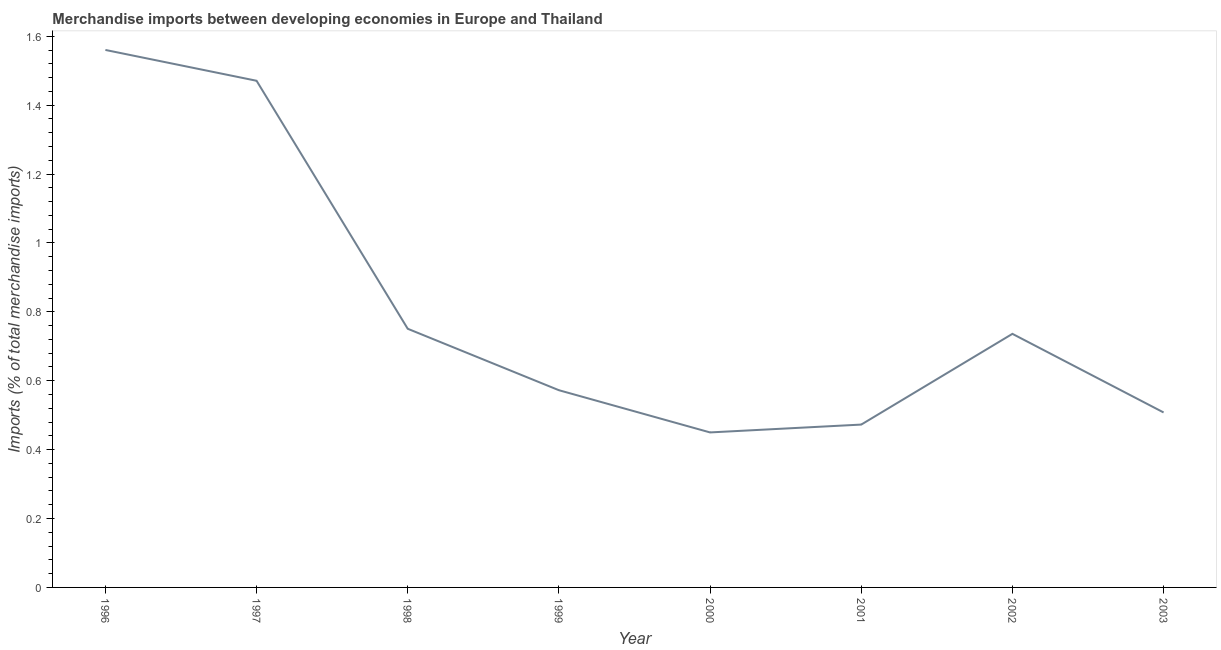What is the merchandise imports in 2002?
Your answer should be compact. 0.74. Across all years, what is the maximum merchandise imports?
Offer a very short reply. 1.56. Across all years, what is the minimum merchandise imports?
Provide a short and direct response. 0.45. What is the sum of the merchandise imports?
Make the answer very short. 6.52. What is the difference between the merchandise imports in 1996 and 1999?
Provide a succinct answer. 0.99. What is the average merchandise imports per year?
Your response must be concise. 0.82. What is the median merchandise imports?
Offer a very short reply. 0.65. In how many years, is the merchandise imports greater than 0.44 %?
Make the answer very short. 8. Do a majority of the years between 2001 and 2002 (inclusive) have merchandise imports greater than 1 %?
Ensure brevity in your answer.  No. What is the ratio of the merchandise imports in 1996 to that in 2002?
Give a very brief answer. 2.12. What is the difference between the highest and the second highest merchandise imports?
Give a very brief answer. 0.09. Is the sum of the merchandise imports in 1997 and 1998 greater than the maximum merchandise imports across all years?
Ensure brevity in your answer.  Yes. What is the difference between the highest and the lowest merchandise imports?
Your answer should be very brief. 1.11. Does the merchandise imports monotonically increase over the years?
Offer a very short reply. No. How many years are there in the graph?
Provide a short and direct response. 8. What is the difference between two consecutive major ticks on the Y-axis?
Give a very brief answer. 0.2. Does the graph contain grids?
Make the answer very short. No. What is the title of the graph?
Provide a short and direct response. Merchandise imports between developing economies in Europe and Thailand. What is the label or title of the X-axis?
Ensure brevity in your answer.  Year. What is the label or title of the Y-axis?
Provide a succinct answer. Imports (% of total merchandise imports). What is the Imports (% of total merchandise imports) of 1996?
Your response must be concise. 1.56. What is the Imports (% of total merchandise imports) of 1997?
Your response must be concise. 1.47. What is the Imports (% of total merchandise imports) in 1998?
Ensure brevity in your answer.  0.75. What is the Imports (% of total merchandise imports) of 1999?
Offer a very short reply. 0.57. What is the Imports (% of total merchandise imports) of 2000?
Give a very brief answer. 0.45. What is the Imports (% of total merchandise imports) in 2001?
Your response must be concise. 0.47. What is the Imports (% of total merchandise imports) of 2002?
Make the answer very short. 0.74. What is the Imports (% of total merchandise imports) in 2003?
Give a very brief answer. 0.51. What is the difference between the Imports (% of total merchandise imports) in 1996 and 1997?
Provide a short and direct response. 0.09. What is the difference between the Imports (% of total merchandise imports) in 1996 and 1998?
Offer a very short reply. 0.81. What is the difference between the Imports (% of total merchandise imports) in 1996 and 1999?
Provide a succinct answer. 0.99. What is the difference between the Imports (% of total merchandise imports) in 1996 and 2000?
Provide a short and direct response. 1.11. What is the difference between the Imports (% of total merchandise imports) in 1996 and 2001?
Offer a very short reply. 1.09. What is the difference between the Imports (% of total merchandise imports) in 1996 and 2002?
Your answer should be very brief. 0.82. What is the difference between the Imports (% of total merchandise imports) in 1996 and 2003?
Keep it short and to the point. 1.05. What is the difference between the Imports (% of total merchandise imports) in 1997 and 1998?
Offer a terse response. 0.72. What is the difference between the Imports (% of total merchandise imports) in 1997 and 1999?
Your response must be concise. 0.9. What is the difference between the Imports (% of total merchandise imports) in 1997 and 2000?
Give a very brief answer. 1.02. What is the difference between the Imports (% of total merchandise imports) in 1997 and 2001?
Provide a succinct answer. 1. What is the difference between the Imports (% of total merchandise imports) in 1997 and 2002?
Your response must be concise. 0.73. What is the difference between the Imports (% of total merchandise imports) in 1997 and 2003?
Keep it short and to the point. 0.96. What is the difference between the Imports (% of total merchandise imports) in 1998 and 1999?
Keep it short and to the point. 0.18. What is the difference between the Imports (% of total merchandise imports) in 1998 and 2000?
Make the answer very short. 0.3. What is the difference between the Imports (% of total merchandise imports) in 1998 and 2001?
Your answer should be compact. 0.28. What is the difference between the Imports (% of total merchandise imports) in 1998 and 2002?
Offer a very short reply. 0.01. What is the difference between the Imports (% of total merchandise imports) in 1998 and 2003?
Your response must be concise. 0.24. What is the difference between the Imports (% of total merchandise imports) in 1999 and 2000?
Offer a terse response. 0.12. What is the difference between the Imports (% of total merchandise imports) in 1999 and 2001?
Keep it short and to the point. 0.1. What is the difference between the Imports (% of total merchandise imports) in 1999 and 2002?
Your answer should be very brief. -0.16. What is the difference between the Imports (% of total merchandise imports) in 1999 and 2003?
Provide a succinct answer. 0.06. What is the difference between the Imports (% of total merchandise imports) in 2000 and 2001?
Give a very brief answer. -0.02. What is the difference between the Imports (% of total merchandise imports) in 2000 and 2002?
Keep it short and to the point. -0.29. What is the difference between the Imports (% of total merchandise imports) in 2000 and 2003?
Offer a very short reply. -0.06. What is the difference between the Imports (% of total merchandise imports) in 2001 and 2002?
Give a very brief answer. -0.26. What is the difference between the Imports (% of total merchandise imports) in 2001 and 2003?
Ensure brevity in your answer.  -0.04. What is the difference between the Imports (% of total merchandise imports) in 2002 and 2003?
Ensure brevity in your answer.  0.23. What is the ratio of the Imports (% of total merchandise imports) in 1996 to that in 1997?
Give a very brief answer. 1.06. What is the ratio of the Imports (% of total merchandise imports) in 1996 to that in 1998?
Your answer should be compact. 2.08. What is the ratio of the Imports (% of total merchandise imports) in 1996 to that in 1999?
Provide a short and direct response. 2.73. What is the ratio of the Imports (% of total merchandise imports) in 1996 to that in 2000?
Your answer should be very brief. 3.47. What is the ratio of the Imports (% of total merchandise imports) in 1996 to that in 2001?
Provide a short and direct response. 3.3. What is the ratio of the Imports (% of total merchandise imports) in 1996 to that in 2002?
Offer a terse response. 2.12. What is the ratio of the Imports (% of total merchandise imports) in 1996 to that in 2003?
Your answer should be very brief. 3.07. What is the ratio of the Imports (% of total merchandise imports) in 1997 to that in 1998?
Keep it short and to the point. 1.96. What is the ratio of the Imports (% of total merchandise imports) in 1997 to that in 1999?
Make the answer very short. 2.57. What is the ratio of the Imports (% of total merchandise imports) in 1997 to that in 2000?
Make the answer very short. 3.27. What is the ratio of the Imports (% of total merchandise imports) in 1997 to that in 2001?
Keep it short and to the point. 3.11. What is the ratio of the Imports (% of total merchandise imports) in 1997 to that in 2002?
Your answer should be compact. 2. What is the ratio of the Imports (% of total merchandise imports) in 1997 to that in 2003?
Offer a terse response. 2.9. What is the ratio of the Imports (% of total merchandise imports) in 1998 to that in 1999?
Ensure brevity in your answer.  1.31. What is the ratio of the Imports (% of total merchandise imports) in 1998 to that in 2000?
Your answer should be compact. 1.67. What is the ratio of the Imports (% of total merchandise imports) in 1998 to that in 2001?
Keep it short and to the point. 1.59. What is the ratio of the Imports (% of total merchandise imports) in 1998 to that in 2002?
Ensure brevity in your answer.  1.02. What is the ratio of the Imports (% of total merchandise imports) in 1998 to that in 2003?
Make the answer very short. 1.48. What is the ratio of the Imports (% of total merchandise imports) in 1999 to that in 2000?
Provide a succinct answer. 1.27. What is the ratio of the Imports (% of total merchandise imports) in 1999 to that in 2001?
Your answer should be very brief. 1.21. What is the ratio of the Imports (% of total merchandise imports) in 1999 to that in 2002?
Provide a short and direct response. 0.78. What is the ratio of the Imports (% of total merchandise imports) in 1999 to that in 2003?
Ensure brevity in your answer.  1.13. What is the ratio of the Imports (% of total merchandise imports) in 2000 to that in 2002?
Offer a very short reply. 0.61. What is the ratio of the Imports (% of total merchandise imports) in 2000 to that in 2003?
Your response must be concise. 0.89. What is the ratio of the Imports (% of total merchandise imports) in 2001 to that in 2002?
Offer a terse response. 0.64. What is the ratio of the Imports (% of total merchandise imports) in 2002 to that in 2003?
Your answer should be compact. 1.45. 